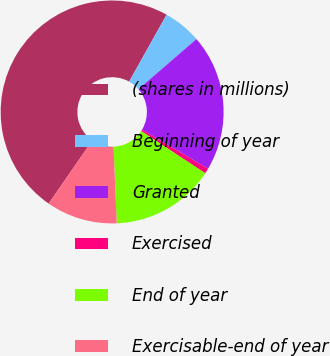Convert chart to OTSL. <chart><loc_0><loc_0><loc_500><loc_500><pie_chart><fcel>(shares in millions)<fcel>Beginning of year<fcel>Granted<fcel>Exercised<fcel>End of year<fcel>Exercisable-end of year<nl><fcel>48.48%<fcel>5.53%<fcel>19.85%<fcel>0.76%<fcel>15.08%<fcel>10.3%<nl></chart> 